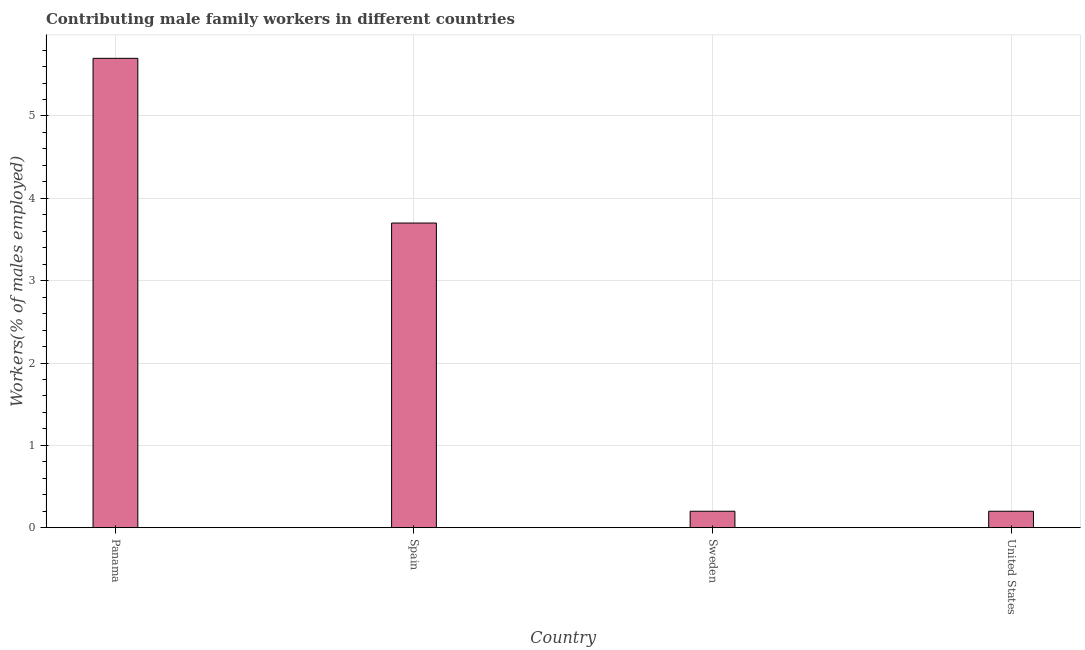Does the graph contain any zero values?
Your response must be concise. No. Does the graph contain grids?
Offer a very short reply. Yes. What is the title of the graph?
Offer a very short reply. Contributing male family workers in different countries. What is the label or title of the Y-axis?
Your answer should be compact. Workers(% of males employed). What is the contributing male family workers in Spain?
Offer a very short reply. 3.7. Across all countries, what is the maximum contributing male family workers?
Offer a very short reply. 5.7. Across all countries, what is the minimum contributing male family workers?
Provide a short and direct response. 0.2. In which country was the contributing male family workers maximum?
Provide a succinct answer. Panama. In which country was the contributing male family workers minimum?
Ensure brevity in your answer.  Sweden. What is the sum of the contributing male family workers?
Your answer should be very brief. 9.8. What is the average contributing male family workers per country?
Give a very brief answer. 2.45. What is the median contributing male family workers?
Ensure brevity in your answer.  1.95. In how many countries, is the contributing male family workers greater than 2.4 %?
Provide a succinct answer. 2. Is the difference between the contributing male family workers in Spain and United States greater than the difference between any two countries?
Provide a succinct answer. No. Is the sum of the contributing male family workers in Spain and Sweden greater than the maximum contributing male family workers across all countries?
Offer a very short reply. No. How many countries are there in the graph?
Offer a terse response. 4. What is the difference between two consecutive major ticks on the Y-axis?
Offer a very short reply. 1. Are the values on the major ticks of Y-axis written in scientific E-notation?
Ensure brevity in your answer.  No. What is the Workers(% of males employed) of Panama?
Provide a succinct answer. 5.7. What is the Workers(% of males employed) of Spain?
Keep it short and to the point. 3.7. What is the Workers(% of males employed) in Sweden?
Ensure brevity in your answer.  0.2. What is the Workers(% of males employed) in United States?
Ensure brevity in your answer.  0.2. What is the difference between the Workers(% of males employed) in Panama and Spain?
Give a very brief answer. 2. What is the difference between the Workers(% of males employed) in Panama and United States?
Provide a short and direct response. 5.5. What is the difference between the Workers(% of males employed) in Spain and United States?
Your answer should be compact. 3.5. What is the ratio of the Workers(% of males employed) in Panama to that in Spain?
Offer a very short reply. 1.54. What is the ratio of the Workers(% of males employed) in Panama to that in Sweden?
Give a very brief answer. 28.5. What is the ratio of the Workers(% of males employed) in Panama to that in United States?
Your answer should be very brief. 28.5. What is the ratio of the Workers(% of males employed) in Spain to that in Sweden?
Your response must be concise. 18.5. What is the ratio of the Workers(% of males employed) in Sweden to that in United States?
Ensure brevity in your answer.  1. 